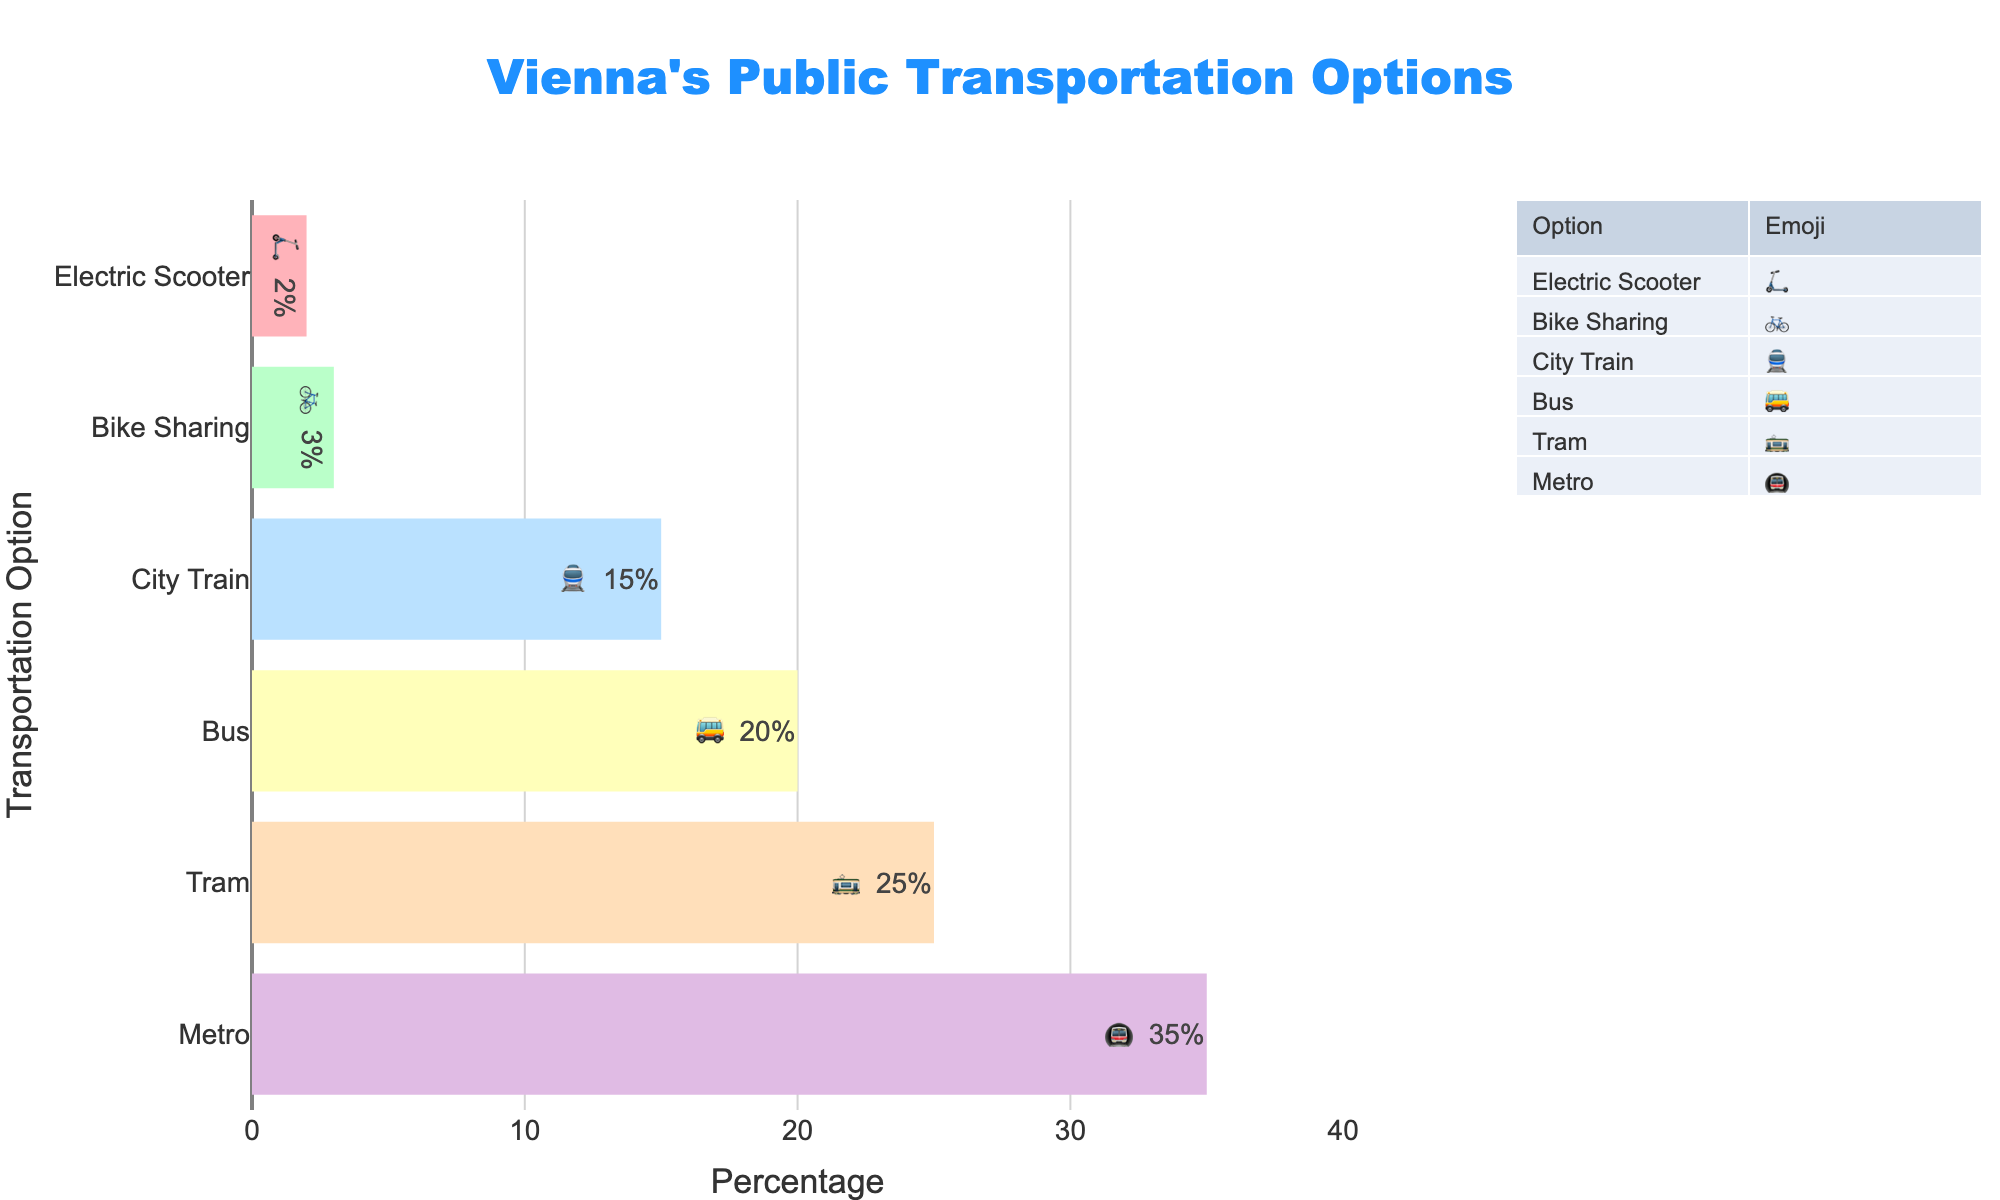What percentage of Vienna's public transportation is covered by the Metro? Look at the bar chart and find the percentage corresponding to the 🚇 emoji for Metro.
Answer: 35% Which transportation option has the lowest percentage, and what is its corresponding emoji? Identify the transportation with the smallest bar in the chart and note its percentage and emoji.
Answer: Electric Scooter, 🛴 What is the combined percentage of Tram and Bus? Find the percentages for Tram (🚋) and Bus (🚌), then add them: 25% + 20%.
Answer: 45% Which transportation option has a higher percentage, Tram or City Train? Compare the lengths of the bars and the percentages: Tram (25%) vs. City Train (15%).
Answer: Tram What are the percentages of Metro and Bike Sharing combined? Sum the percentages of Metro (35%) and Bike Sharing (3%): 35% + 3%.
Answer: 38% How many different transport options are shown in the figure? Count the number of distinct transportation options listed in the bar chart.
Answer: 6 Which transportation option is right in the middle in terms of percentage, and what is its percentage? Find the median transportation by percentage values (ordered as 2%, 3%, 15%, 20%, 25%, 35%): City Train (15%) and Bus (20%) are middle values.
Answer: Bus, 20% What is the range of the percentages covered by the public transportation options? Subtract the smallest percentage (2% for Electric Scooter) from the largest (35% for Metro): 35% - 2%.
Answer: 33% Compare the total percentage of Metro and Tram to the total percentage of Bus and City Train. Which group has a higher total percentage? Sum the percentages of the two groups: Metro + Tram (35% + 25%) vs. Bus + City Train (20% + 15%). Compare 60% vs 35%.
Answer: Metro and Tram What is the second least popular transportation option, and what is its percentage and emoji? Identify the second smallest bar in the chart, just larger than Electric Scooter (2%): Bike Sharing (3%).
Answer: Bike Sharing, 3%, 🚲 